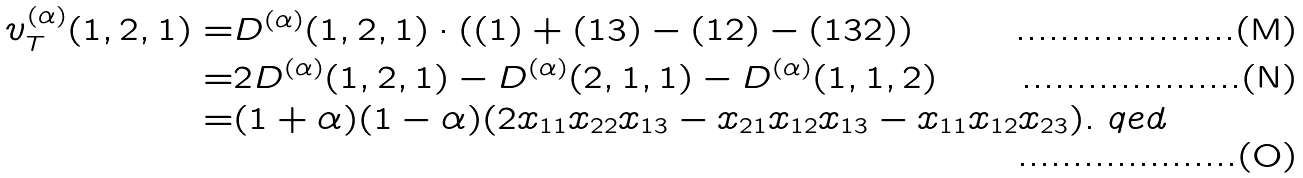<formula> <loc_0><loc_0><loc_500><loc_500>v _ { T } ^ { ( \alpha ) } ( 1 , 2 , 1 ) = & D ^ { ( \alpha ) } ( 1 , 2 , 1 ) \cdot ( ( 1 ) + ( 1 3 ) - ( 1 2 ) - ( 1 3 2 ) ) \\ = & 2 D ^ { ( \alpha ) } ( 1 , 2 , 1 ) - D ^ { ( \alpha ) } ( 2 , 1 , 1 ) - D ^ { ( \alpha ) } ( 1 , 1 , 2 ) \\ = & ( 1 + \alpha ) ( 1 - \alpha ) ( 2 x _ { 1 1 } x _ { 2 2 } x _ { 1 3 } - x _ { 2 1 } x _ { 1 2 } x _ { 1 3 } - x _ { 1 1 } x _ { 1 2 } x _ { 2 3 } ) . \ q e d</formula> 